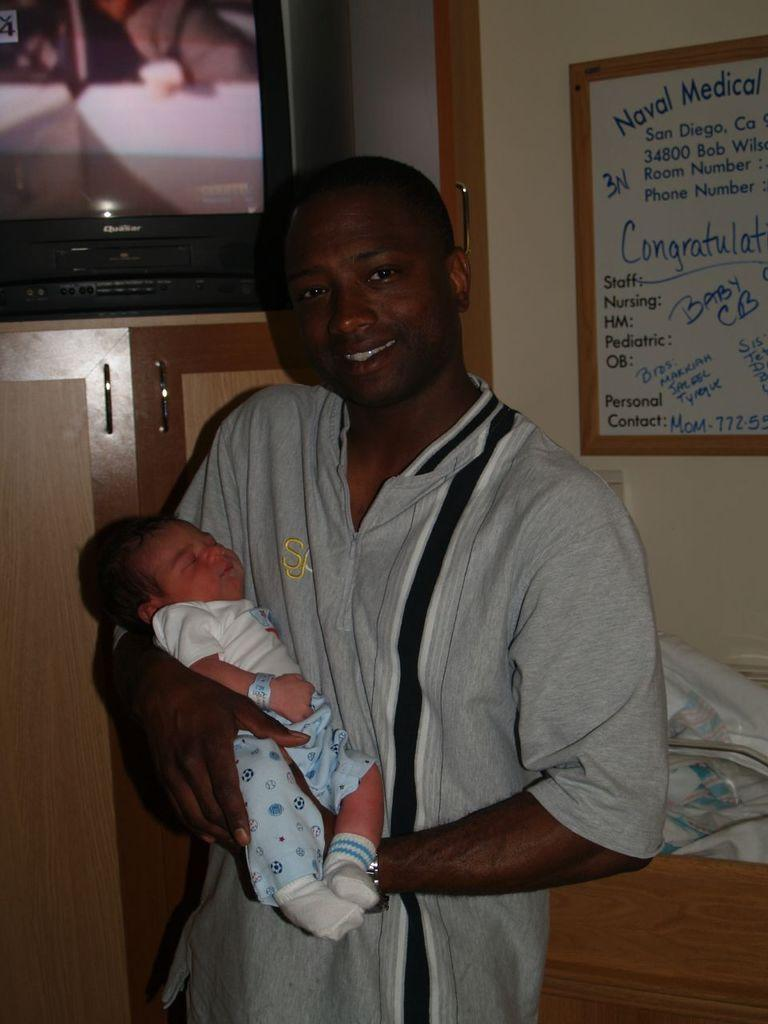What is the man in the image doing? The man is standing in the image and holding a baby in his hands. What can be seen in the background of the image? There is a TV in a shelf and a board on the wall in the background. What might the board on the wall be used for? The board on the wall might be used for displaying information or decoration. What type of insect can be seen crawling on the baby's face in the image? There is no insect present on the baby's face in the image. 